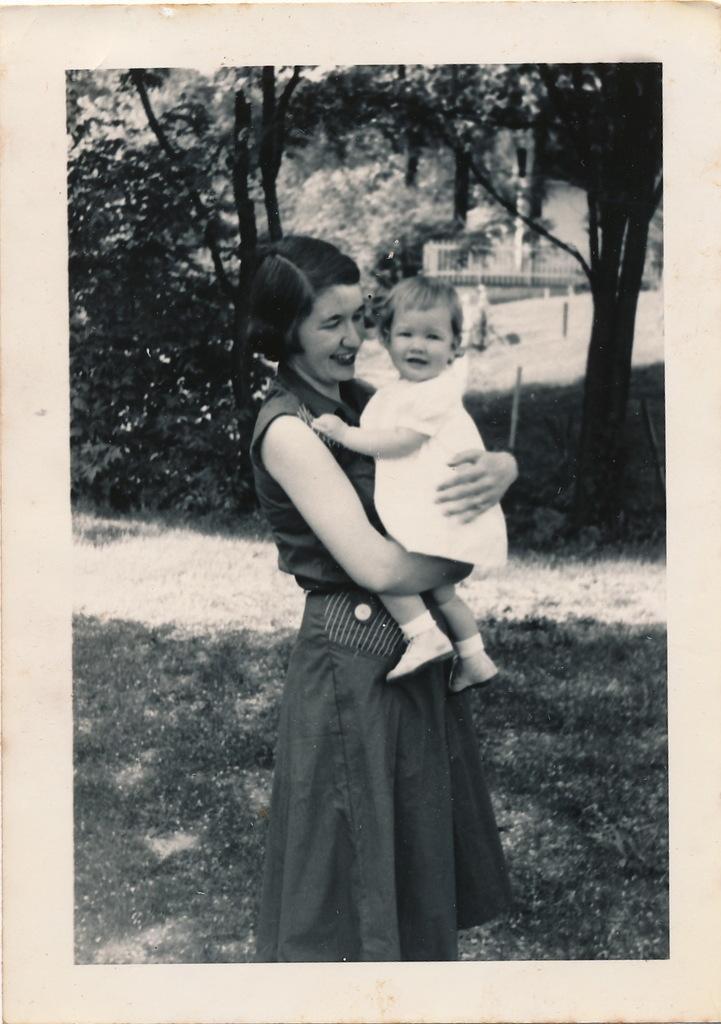Can you describe this image briefly? In this picture we can see photo,on this photo there is a woman standing and holding a baby and smiling and we can see grass. In the background we can see trees. 